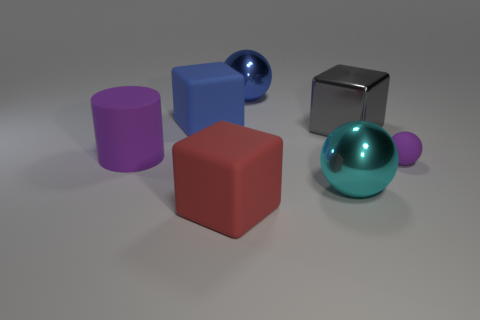Subtract all rubber blocks. How many blocks are left? 1 Subtract 1 cubes. How many cubes are left? 2 Add 2 tiny matte objects. How many objects exist? 9 Subtract all red spheres. How many blue blocks are left? 1 Subtract all big blue metal objects. Subtract all big purple matte things. How many objects are left? 5 Add 6 metal blocks. How many metal blocks are left? 7 Add 7 purple matte objects. How many purple matte objects exist? 9 Subtract 0 yellow balls. How many objects are left? 7 Subtract all cylinders. How many objects are left? 6 Subtract all yellow balls. Subtract all blue cylinders. How many balls are left? 3 